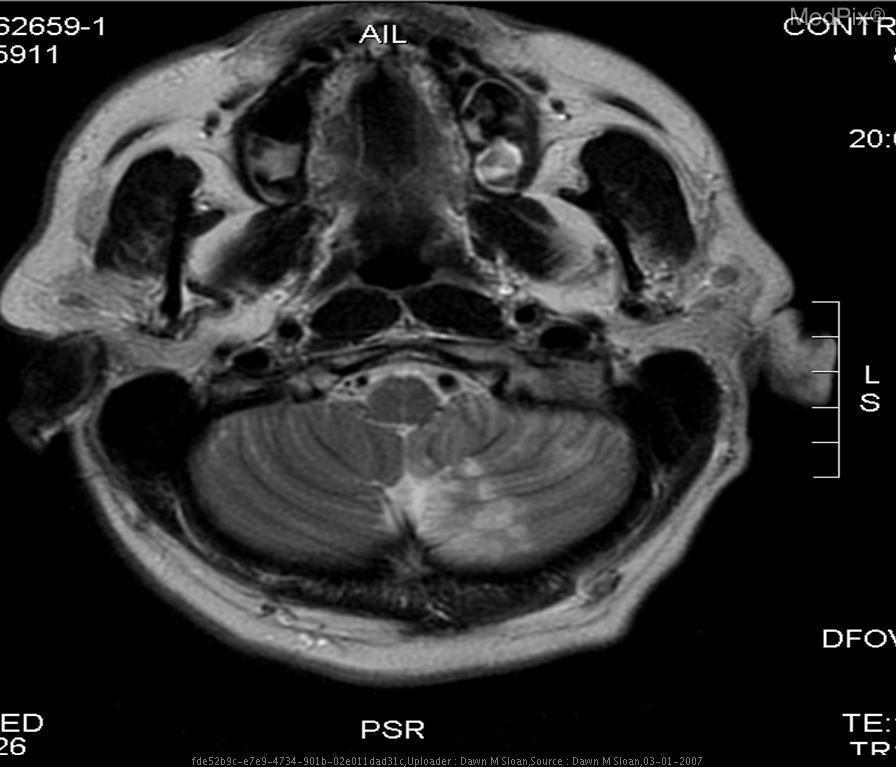Is there any shift of midline structures visible in this section?
Concise answer only. No. Is there shifting of structures across the middle?
Answer briefly. No. Are the cerebellar infarcts hyper attenuated?
Give a very brief answer. Yes. Was this image taken without motion artifact
Concise answer only. Yes. Has the brainstem herniated?
Answer briefly. No. Is there evidence of brainstem herniation in this section
Be succinct. No. Is this an image of the cerebellum
Quick response, please. Yes. Are the vertebral arteries patent in this section?
Keep it brief. Yes. Are the vertebral arteries in view?
Give a very brief answer. Yes. Is the plane of section transverse?
Concise answer only. Yes. 